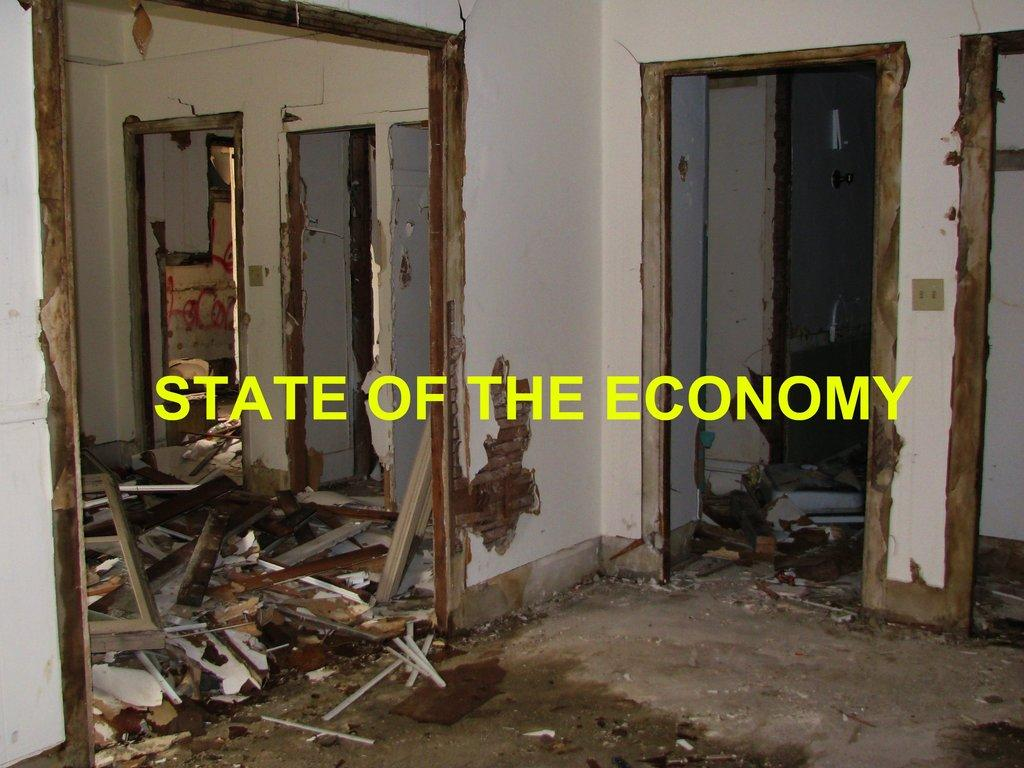What type of location is depicted in the image? The image is an inside view of a building. What material can be seen in the image? There is wood visible in the image. What architectural feature is present in the image? There is a wall in the image. What type of hill can be seen in the image? There is no hill present in the image; it is an inside view of a building. What kind of horn is being played in the image? There is no horn or musical instrument present in the image. 